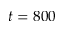<formula> <loc_0><loc_0><loc_500><loc_500>t = 8 0 0</formula> 